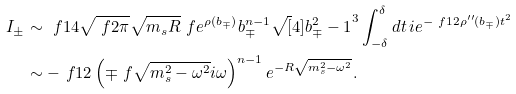Convert formula to latex. <formula><loc_0><loc_0><loc_500><loc_500>I _ { \pm } & \sim \ f { 1 } { 4 } \sqrt { \ f { 2 } { \pi } } \sqrt { m _ { s } R } \ f { e ^ { \rho ( b _ { \mp } ) } } { b _ { \mp } ^ { n - 1 } \sqrt { [ } 4 ] { b _ { \mp } ^ { 2 } - 1 } ^ { 3 } } \int _ { - \delta } ^ { \delta } d t \, i e ^ { - \ f { 1 } { 2 } \rho ^ { \prime \prime } ( b _ { \mp } ) t ^ { 2 } } \\ & \sim - \ f { 1 } { 2 } \left ( \mp \ f { \sqrt { m _ { s } ^ { 2 } - \omega ^ { 2 } } } { i \omega } \right ) ^ { n - 1 } e ^ { - R \sqrt { m _ { s } ^ { 2 } - \omega ^ { 2 } } } .</formula> 